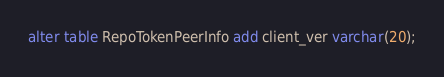Convert code to text. <code><loc_0><loc_0><loc_500><loc_500><_SQL_>alter table RepoTokenPeerInfo add client_ver varchar(20);</code> 